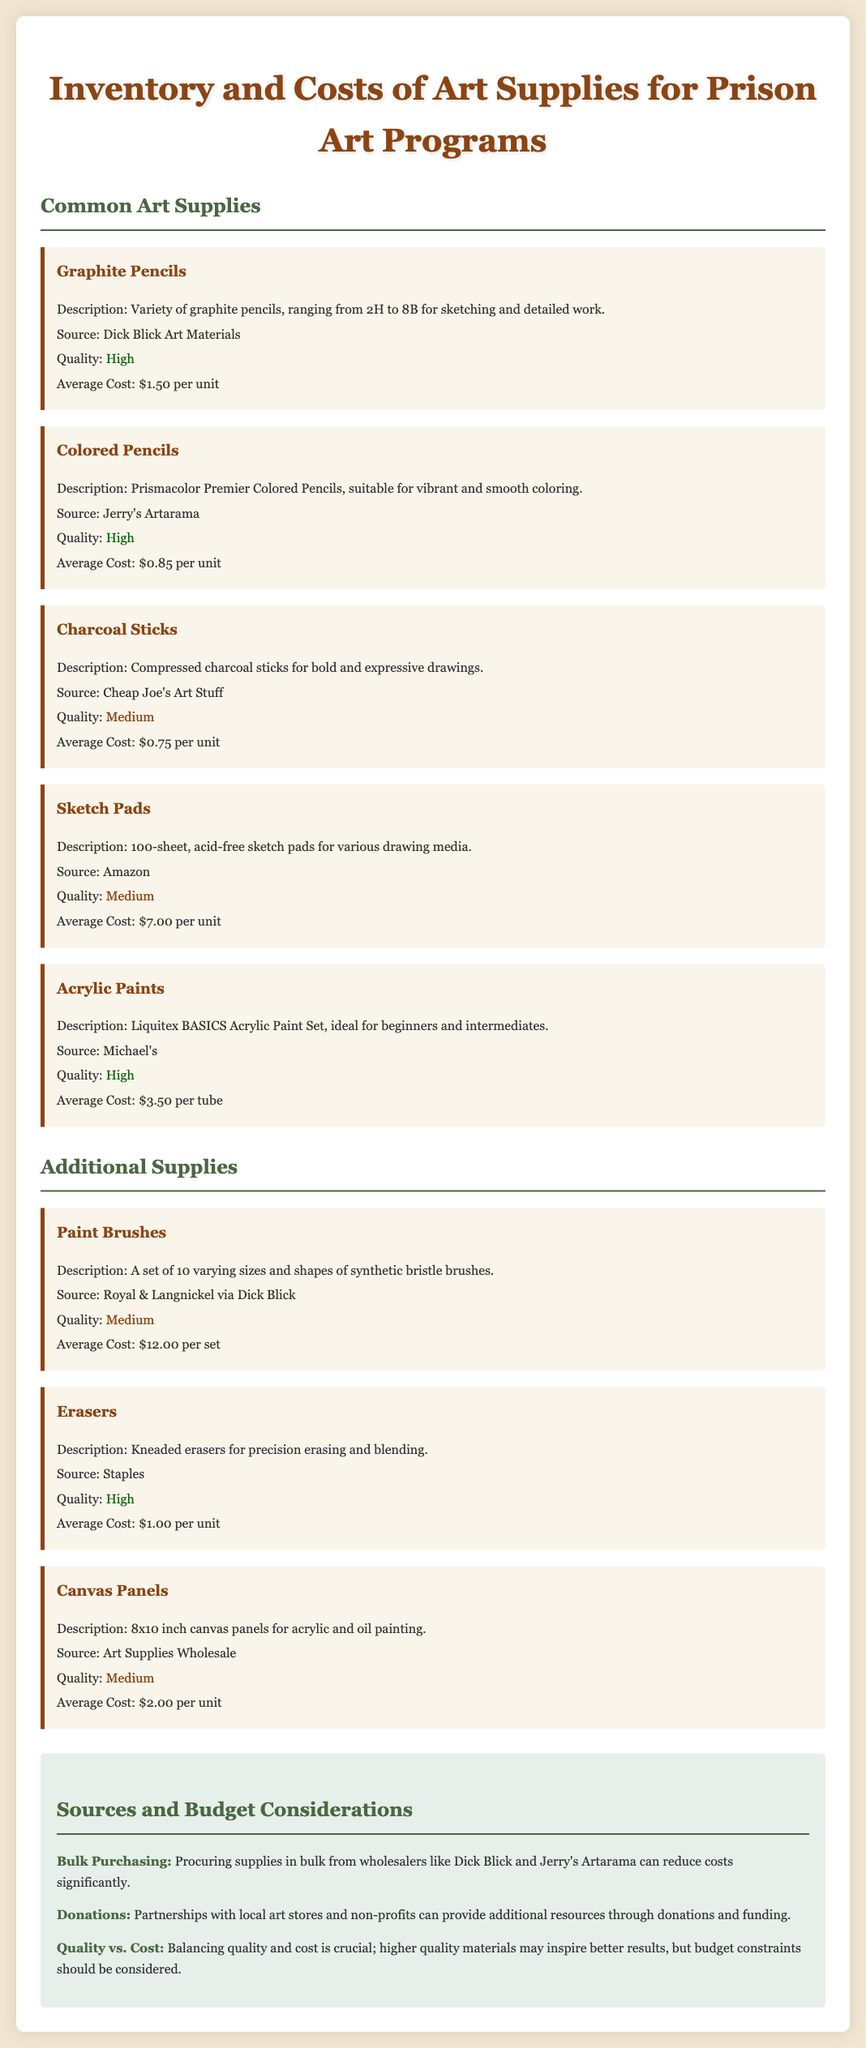What is the average cost of Graphite Pencils? The average cost of Graphite Pencils is specifically mentioned in the document as $1.50 per unit.
Answer: $1.50 Which supplier provides Colored Pencils? The document specifies that Colored Pencils are sourced from Jerry's Artarama.
Answer: Jerry's Artarama What quality is assigned to Charcoal Sticks? The quality of Charcoal Sticks is categorized as Medium according to the document.
Answer: Medium How many paint brushes are in a set? The document states that a set contains 10 varying sizes and shapes of paint brushes.
Answer: 10 What type of eraser is mentioned in the document? The document describes the erasers as kneaded erasers for precision erasing and blending.
Answer: Kneaded erasers What is one benefit of bulk purchasing mentioned in the document? The document states that procuring supplies in bulk can significantly reduce costs, illustrating a key benefit.
Answer: Reduce costs Which art supply is ideal for beginners and intermediates? According to the document, the Liquitex BASICS Acrylic Paint Set is ideal for beginners and intermediates.
Answer: Liquitex BASICS Acrylic Paint Set What is the average cost of Canvas Panels? The document specifies the average cost of Canvas Panels as $2.00 per unit.
Answer: $2.00 What is one partnership opportunity mentioned for additional resources? The document notes that partnerships with local art stores can provide resources through donations.
Answer: Local art stores 